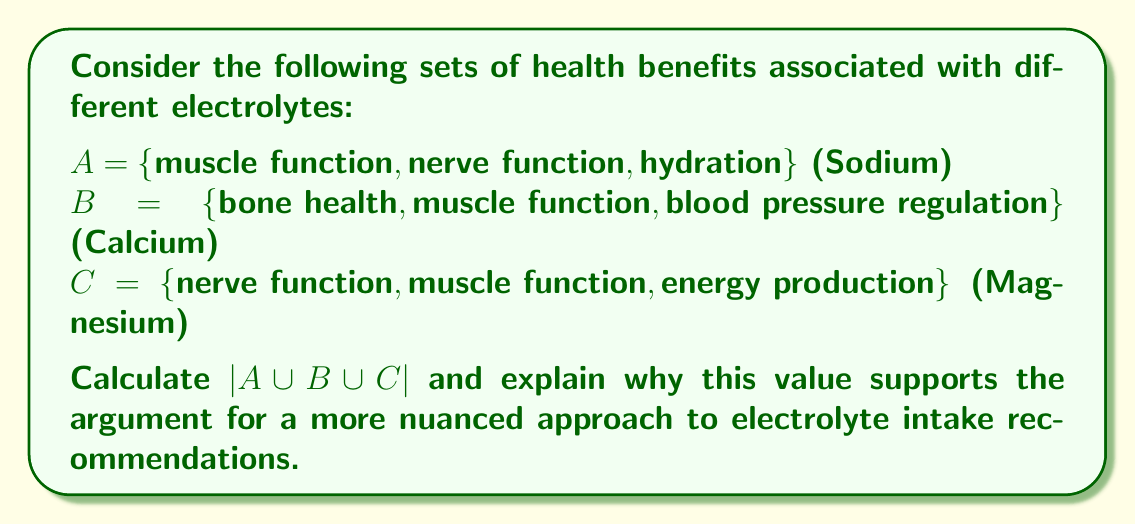Give your solution to this math problem. To solve this problem, we'll use the principle of inclusion-exclusion for three sets:

$$|A \cup B \cup C| = |A| + |B| + |C| - |A \cap B| - |A \cap C| - |B \cap C| + |A \cap B \cap C|$$

Let's break it down step-by-step:

1. First, we need to determine the cardinality of each set:
   $|A| = 3$, $|B| = 3$, $|C| = 3$

2. Next, we find the intersections:
   $A \cap B = \{\text{muscle function}\}$, so $|A \cap B| = 1$
   $A \cap C = \{\text{muscle function}, \text{nerve function}\}$, so $|A \cap C| = 2$
   $B \cap C = \{\text{muscle function}\}$, so $|B \cap C| = 1$

3. Finally, we find the intersection of all three sets:
   $A \cap B \cap C = \{\text{muscle function}\}$, so $|A \cap B \cap C| = 1$

4. Now we can plug these values into our formula:

   $$|A \cup B \cup C| = 3 + 3 + 3 - 1 - 2 - 1 + 1 = 6$$

This result shows that there are 6 unique health benefits across these three electrolytes. This supports a more nuanced approach to electrolyte intake recommendations because:

1. It demonstrates that different electrolytes have overlapping benefits, suggesting they work synergistically.
2. It shows that each electrolyte contributes unique benefits not provided by the others.
3. The overlap in benefits (like muscle function) emphasizes the importance of balanced intake rather than focusing on a single electrolyte.

This analysis aligns with the persona's view that current regulations on salt (sodium) intake may be oversimplified, as it demonstrates the complex interplay between different electrolytes in maintaining overall health.
Answer: $|A \cup B \cup C| = 6$ 